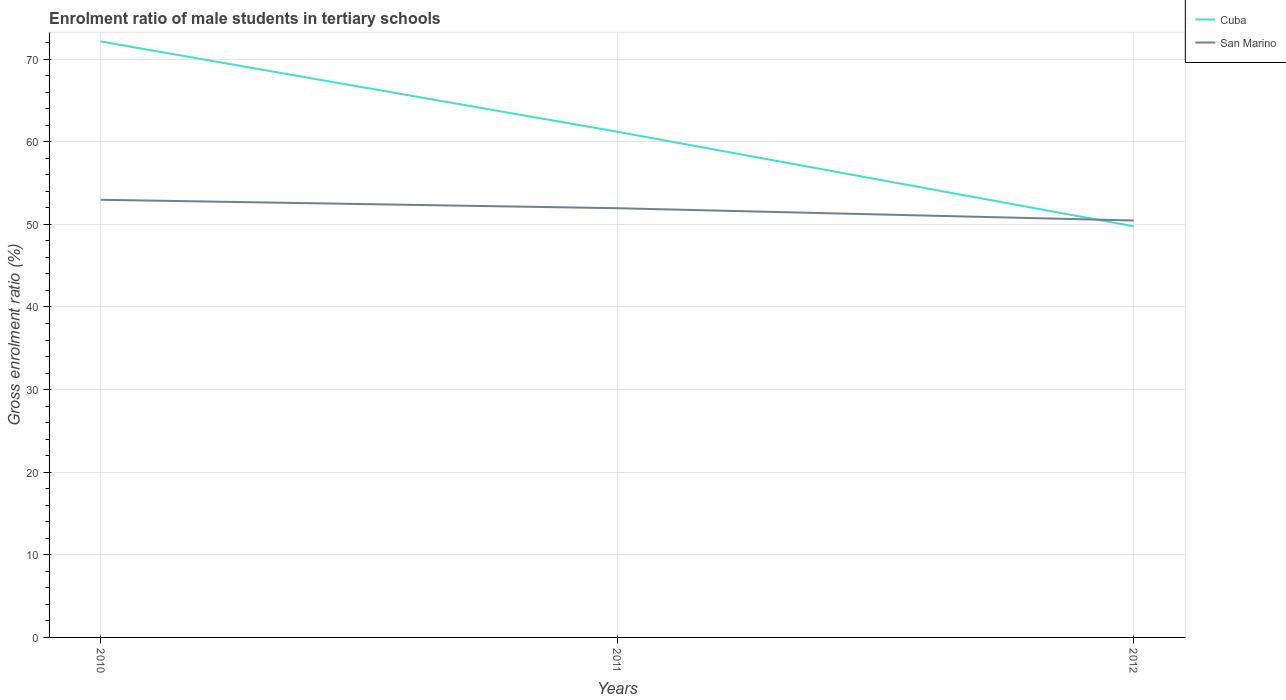How many different coloured lines are there?
Your answer should be very brief. 2. Is the number of lines equal to the number of legend labels?
Keep it short and to the point. Yes. Across all years, what is the maximum enrolment ratio of male students in tertiary schools in San Marino?
Offer a very short reply. 50.46. In which year was the enrolment ratio of male students in tertiary schools in Cuba maximum?
Give a very brief answer. 2012. What is the total enrolment ratio of male students in tertiary schools in Cuba in the graph?
Provide a short and direct response. 10.92. What is the difference between the highest and the second highest enrolment ratio of male students in tertiary schools in San Marino?
Your response must be concise. 2.51. Is the enrolment ratio of male students in tertiary schools in San Marino strictly greater than the enrolment ratio of male students in tertiary schools in Cuba over the years?
Your response must be concise. No. How many lines are there?
Keep it short and to the point. 2. Are the values on the major ticks of Y-axis written in scientific E-notation?
Make the answer very short. No. Does the graph contain any zero values?
Make the answer very short. No. Does the graph contain grids?
Keep it short and to the point. Yes. What is the title of the graph?
Your answer should be compact. Enrolment ratio of male students in tertiary schools. Does "Nepal" appear as one of the legend labels in the graph?
Your response must be concise. No. What is the Gross enrolment ratio (%) of Cuba in 2010?
Your answer should be very brief. 72.13. What is the Gross enrolment ratio (%) in San Marino in 2010?
Your response must be concise. 52.97. What is the Gross enrolment ratio (%) of Cuba in 2011?
Your answer should be very brief. 61.21. What is the Gross enrolment ratio (%) in San Marino in 2011?
Your answer should be very brief. 51.95. What is the Gross enrolment ratio (%) of Cuba in 2012?
Provide a succinct answer. 49.76. What is the Gross enrolment ratio (%) in San Marino in 2012?
Your answer should be very brief. 50.46. Across all years, what is the maximum Gross enrolment ratio (%) of Cuba?
Your answer should be very brief. 72.13. Across all years, what is the maximum Gross enrolment ratio (%) in San Marino?
Offer a terse response. 52.97. Across all years, what is the minimum Gross enrolment ratio (%) in Cuba?
Make the answer very short. 49.76. Across all years, what is the minimum Gross enrolment ratio (%) in San Marino?
Give a very brief answer. 50.46. What is the total Gross enrolment ratio (%) of Cuba in the graph?
Your answer should be very brief. 183.1. What is the total Gross enrolment ratio (%) in San Marino in the graph?
Provide a succinct answer. 155.39. What is the difference between the Gross enrolment ratio (%) of Cuba in 2010 and that in 2011?
Ensure brevity in your answer.  10.92. What is the difference between the Gross enrolment ratio (%) in San Marino in 2010 and that in 2011?
Keep it short and to the point. 1.02. What is the difference between the Gross enrolment ratio (%) in Cuba in 2010 and that in 2012?
Give a very brief answer. 22.37. What is the difference between the Gross enrolment ratio (%) of San Marino in 2010 and that in 2012?
Provide a succinct answer. 2.51. What is the difference between the Gross enrolment ratio (%) of Cuba in 2011 and that in 2012?
Keep it short and to the point. 11.45. What is the difference between the Gross enrolment ratio (%) of San Marino in 2011 and that in 2012?
Keep it short and to the point. 1.49. What is the difference between the Gross enrolment ratio (%) in Cuba in 2010 and the Gross enrolment ratio (%) in San Marino in 2011?
Give a very brief answer. 20.18. What is the difference between the Gross enrolment ratio (%) in Cuba in 2010 and the Gross enrolment ratio (%) in San Marino in 2012?
Provide a short and direct response. 21.67. What is the difference between the Gross enrolment ratio (%) of Cuba in 2011 and the Gross enrolment ratio (%) of San Marino in 2012?
Provide a short and direct response. 10.74. What is the average Gross enrolment ratio (%) in Cuba per year?
Your answer should be compact. 61.03. What is the average Gross enrolment ratio (%) in San Marino per year?
Give a very brief answer. 51.8. In the year 2010, what is the difference between the Gross enrolment ratio (%) in Cuba and Gross enrolment ratio (%) in San Marino?
Your response must be concise. 19.16. In the year 2011, what is the difference between the Gross enrolment ratio (%) in Cuba and Gross enrolment ratio (%) in San Marino?
Provide a short and direct response. 9.26. In the year 2012, what is the difference between the Gross enrolment ratio (%) of Cuba and Gross enrolment ratio (%) of San Marino?
Make the answer very short. -0.7. What is the ratio of the Gross enrolment ratio (%) in Cuba in 2010 to that in 2011?
Offer a terse response. 1.18. What is the ratio of the Gross enrolment ratio (%) of San Marino in 2010 to that in 2011?
Make the answer very short. 1.02. What is the ratio of the Gross enrolment ratio (%) of Cuba in 2010 to that in 2012?
Provide a succinct answer. 1.45. What is the ratio of the Gross enrolment ratio (%) of San Marino in 2010 to that in 2012?
Provide a succinct answer. 1.05. What is the ratio of the Gross enrolment ratio (%) in Cuba in 2011 to that in 2012?
Give a very brief answer. 1.23. What is the ratio of the Gross enrolment ratio (%) in San Marino in 2011 to that in 2012?
Provide a short and direct response. 1.03. What is the difference between the highest and the second highest Gross enrolment ratio (%) in Cuba?
Provide a succinct answer. 10.92. What is the difference between the highest and the second highest Gross enrolment ratio (%) in San Marino?
Offer a terse response. 1.02. What is the difference between the highest and the lowest Gross enrolment ratio (%) in Cuba?
Ensure brevity in your answer.  22.37. What is the difference between the highest and the lowest Gross enrolment ratio (%) of San Marino?
Your answer should be compact. 2.51. 